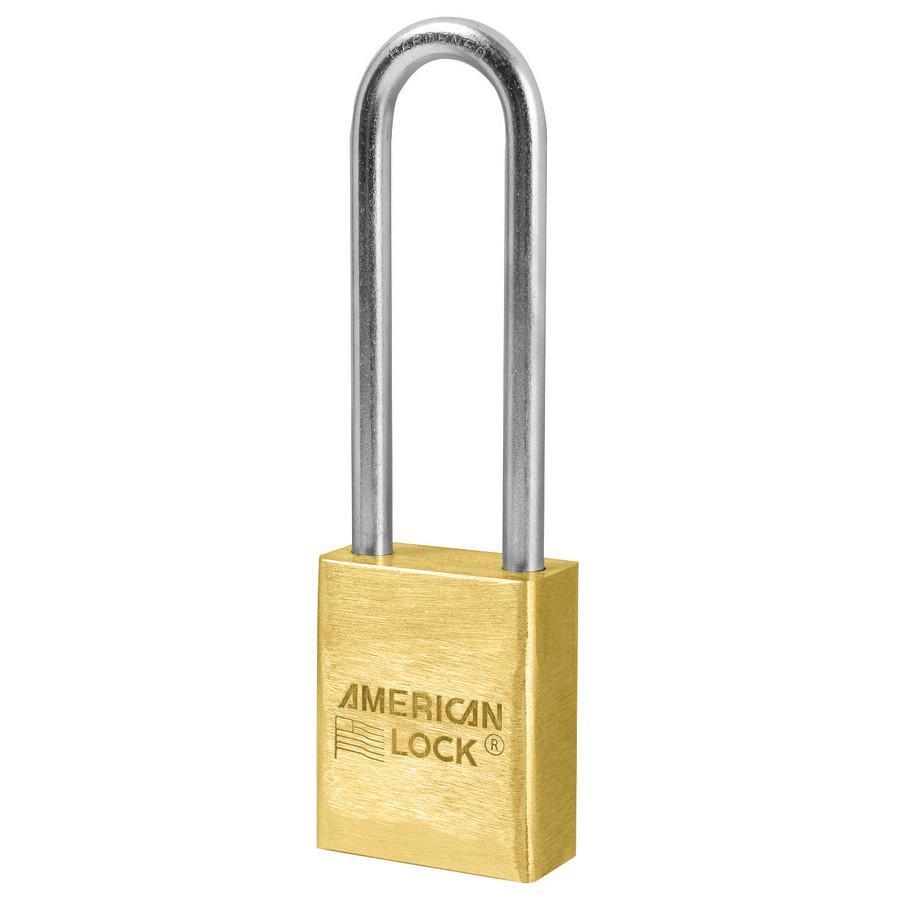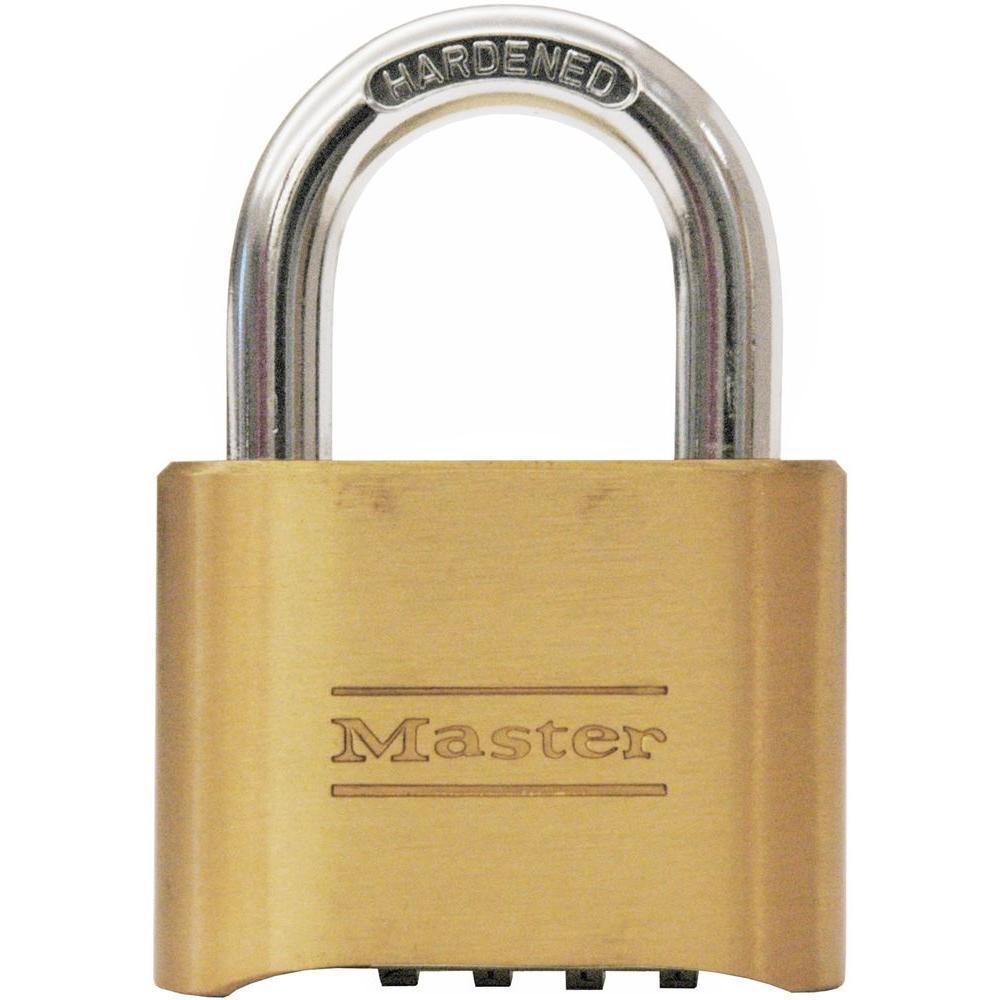The first image is the image on the left, the second image is the image on the right. Considering the images on both sides, is "An image includes a gold-colored lock with a loop taller than the body of the lock, and no keys present." valid? Answer yes or no. Yes. The first image is the image on the left, the second image is the image on the right. Assess this claim about the two images: "The right image contains a lock with at least two keys.". Correct or not? Answer yes or no. No. 